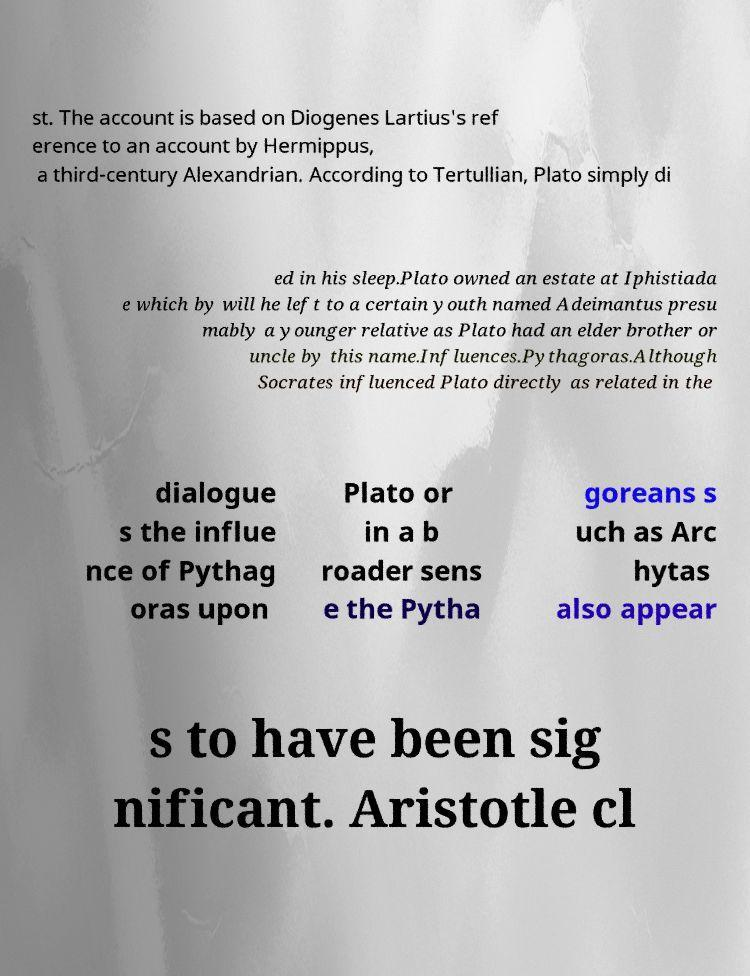Could you extract and type out the text from this image? st. The account is based on Diogenes Lartius's ref erence to an account by Hermippus, a third-century Alexandrian. According to Tertullian, Plato simply di ed in his sleep.Plato owned an estate at Iphistiada e which by will he left to a certain youth named Adeimantus presu mably a younger relative as Plato had an elder brother or uncle by this name.Influences.Pythagoras.Although Socrates influenced Plato directly as related in the dialogue s the influe nce of Pythag oras upon Plato or in a b roader sens e the Pytha goreans s uch as Arc hytas also appear s to have been sig nificant. Aristotle cl 